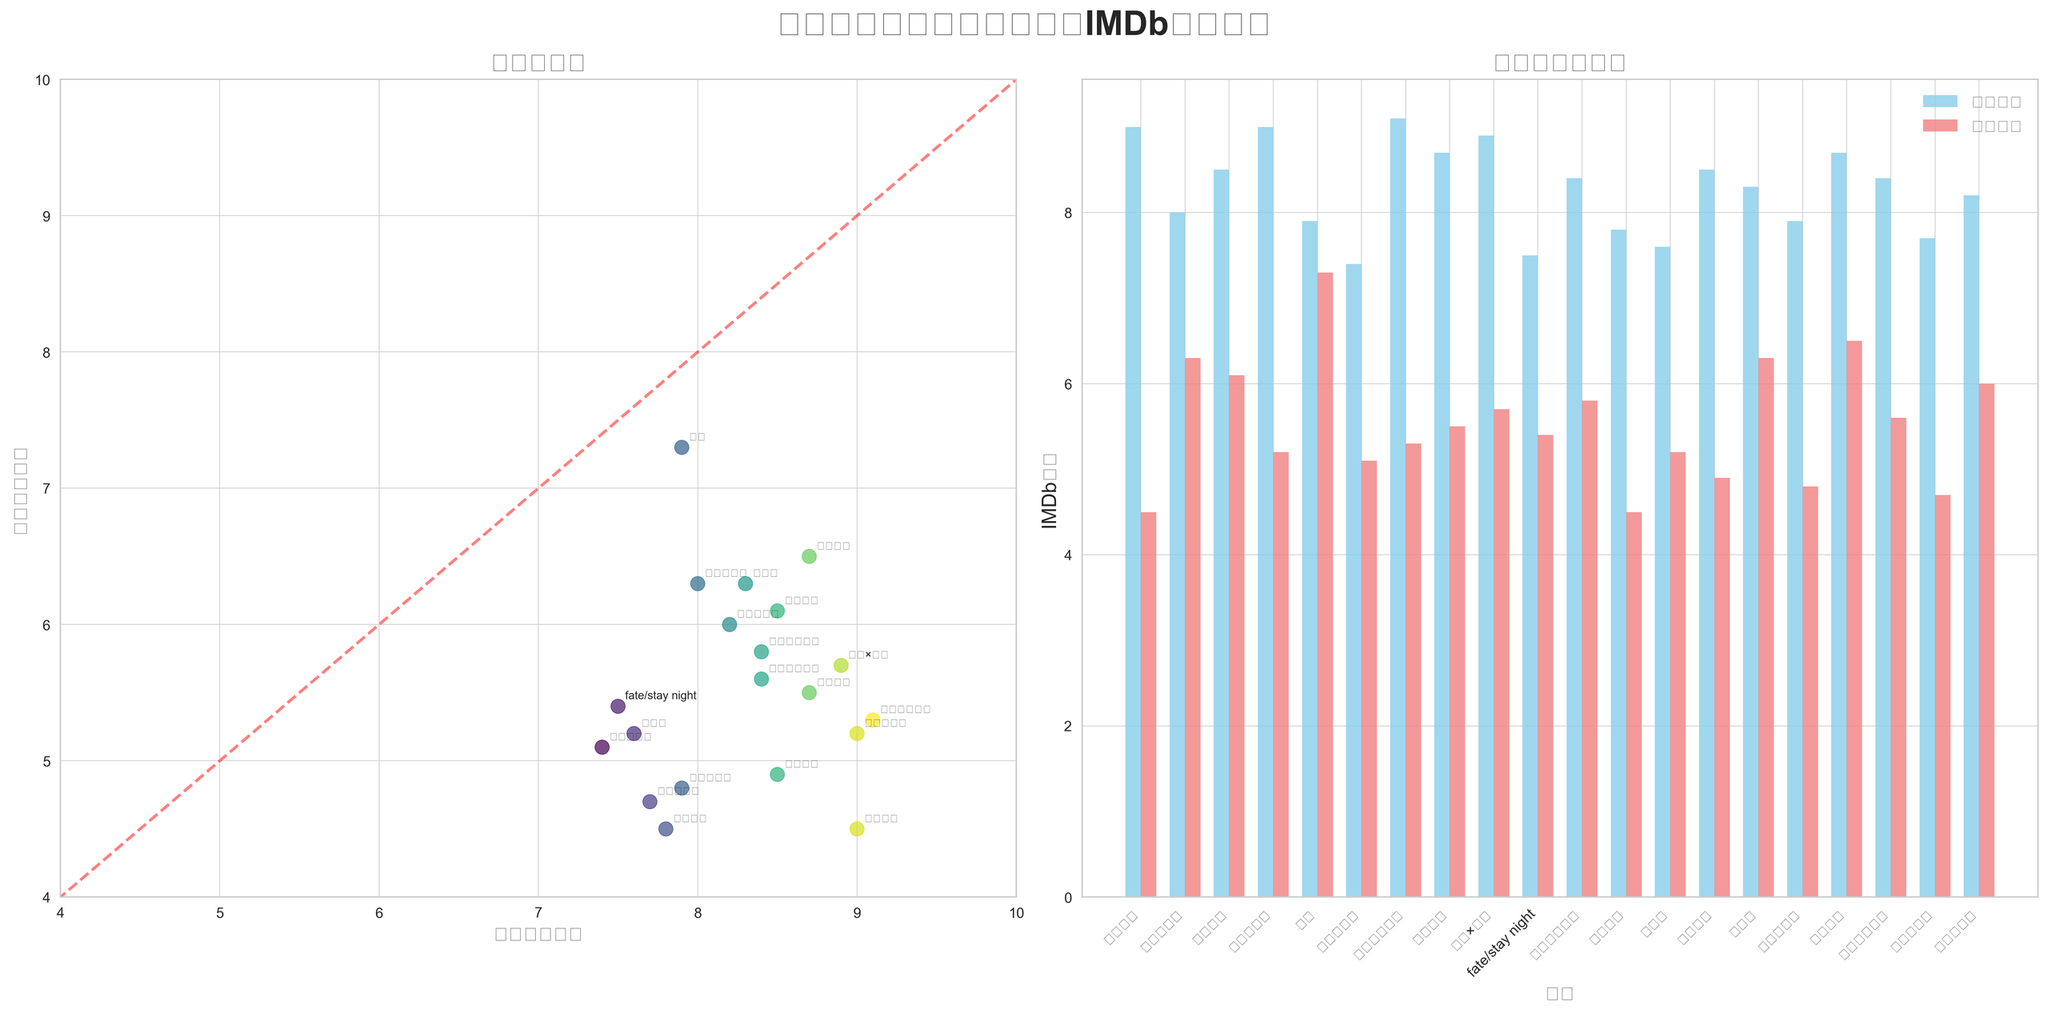哪部动漫改编成的真人电影评分差距最大？ 我们需要找到两个评分差距最大的作品。在柱状图中，死亡笔记的动漫原作评分为9.0，而真人电影评分为4.5，差距为4.5分，这是最大的差距。
Answer: 死亡笔记 动漫原作评分最高的作品是哪一部？ 我们可以看到在散点图和柱状图中，钢之炼金术师的动漫评分最高，为9.1。
Answer: 钢之炼金术师 有哪几部动漫原作和真人电影版本的评分大致相同？ 我们需要在散点图中找到那些接近参考线的点，例如攻壳机动队的两个评分相对接近，分别为8.0和6.3，但并没有完全相同的评分。
Answer: 没有完全相同的 评分在7.0到8.0之间的动漫原作有哪些？ 查看柱状图并注意x轴对应的评分范围，评分在7.0到8.0之间的动漫包括宠物小精灵（7.4）、fate/stay night（7.5）、东京喰种（7.8）、死亡代理人（7.7）、游戏王（7.6）、圣斗士星矢（7.9）。
Answer: 宠物小精灵、fate/stay night、东京喰种、死亡代理人、游戏王、圣斗士星矢 在动漫改编的真人电影中，评分最高的是哪一部？ 看散点图中y轴的最大的值，并从相应的点找到影片名字，可以看到真人电影评分最高的是铳梦，得到了7.3分。
Answer: 铳梦 